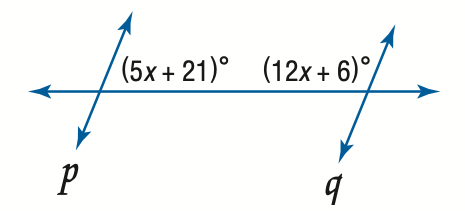Answer the mathemtical geometry problem and directly provide the correct option letter.
Question: Find x so that p \parallel q.
Choices: A: 2.1 B: 9 C: 12.2 D: 66 B 